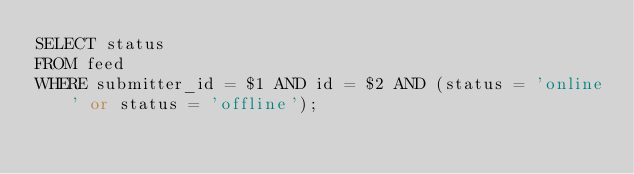Convert code to text. <code><loc_0><loc_0><loc_500><loc_500><_SQL_>SELECT status 
FROM feed
WHERE submitter_id = $1 AND id = $2 AND (status = 'online' or status = 'offline');
</code> 